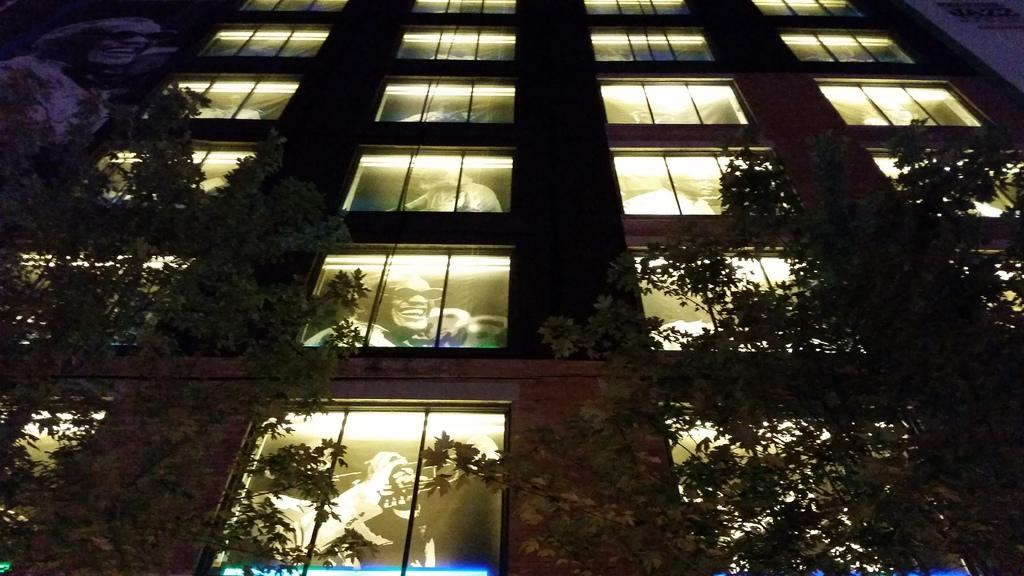What type of structure is visible in the image? There is a building in the image. What feature can be observed on the building? The building has glass windows. What is depicted on the glass windows? There are paintings of persons on the windows. What can be seen in front of the building? There are trees before the building. What type of vest can be seen hanging on the trees before the building? There is no vest present in the image; it only features a building with glass windows and paintings of persons, as well as trees in front of it. 